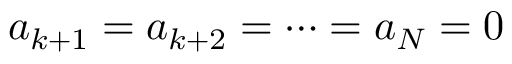<formula> <loc_0><loc_0><loc_500><loc_500>a _ { k + 1 } = a _ { k + 2 } = \cdots = a _ { N } = 0</formula> 